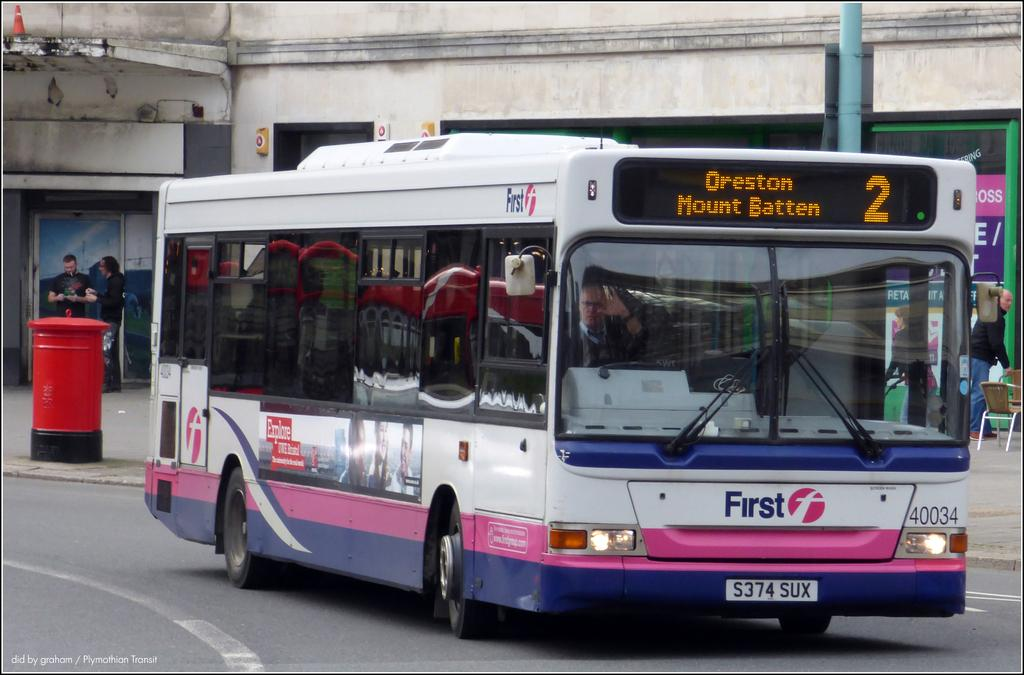<image>
Relay a brief, clear account of the picture shown. A bus on a road that has an ad for First on the front of the bus. 